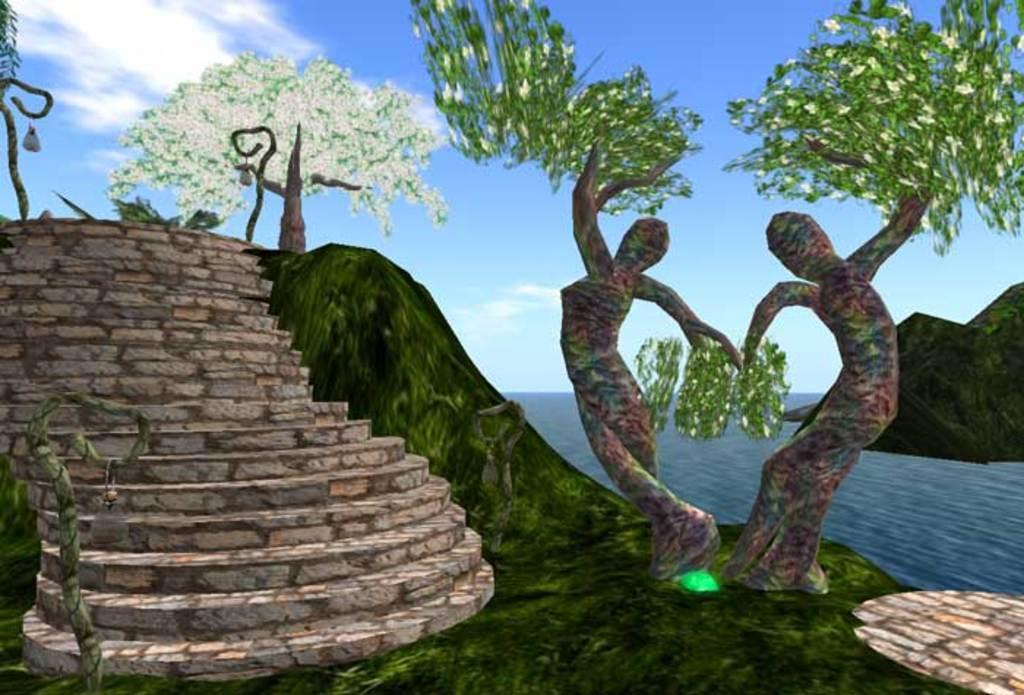Can you describe this image briefly? This image looks like it is animated. On the right, there are trees. On the left, there are steps. At the top, there are clouds in the sky. 